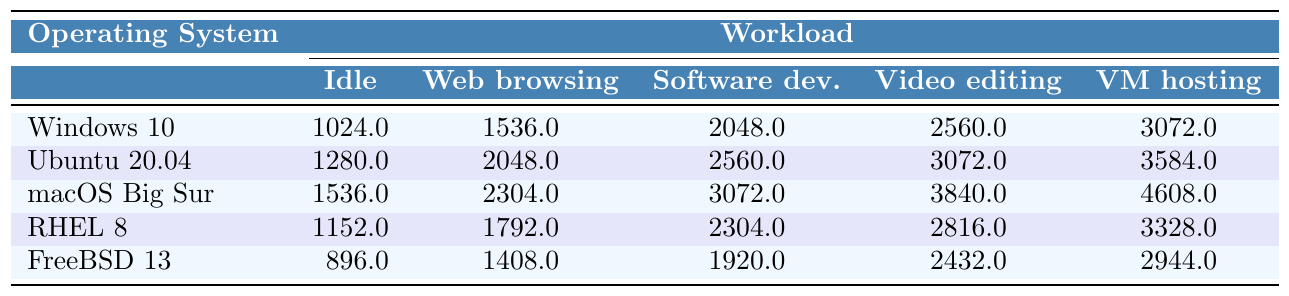What is the memory usage for Ubuntu 20.04 during video editing? From the table, look under Ubuntu 20.04 and the Video editing column. The value is 3072 MB.
Answer: 3072 MB Which operating system has the highest memory usage during software development? Check the Software development column for each operating system. The highest value is 3072 MB, which corresponds to macOS Big Sur.
Answer: macOS Big Sur What is the CPU utilization for FreeBSD 13 when idle? Refer to the Idle column for FreeBSD 13. The value is 1%.
Answer: 1% Which operating system shows the lowest disk I/O when hosting virtual machines? Look at the disk I/O under the VM hosting column. FreeBSD 13 has the lowest value at 90 MBps.
Answer: FreeBSD 13 What is the difference in memory usage between Windows 10 and RHEL 8 during web browsing? The memory usage for Windows 10 during web browsing is 1536 MB, while RHEL 8 is 1792 MB. The difference is 1792 - 1536 = 256 MB.
Answer: 256 MB What is the average memory usage across all operating systems during the idle workload? Sum the memory usage for the Idle column: 1024 + 1280 + 1536 + 1152 + 896 = 4888 MB. There are 5 operating systems, so the average is 4888 / 5 = 977.6 MB.
Answer: 977.6 MB Is Ubuntu 20.04's network usage during software development higher than macOS Big Sur's? For Ubuntu 20.04, the network usage during software development is 7 Mbps, and for macOS Big Sur, it is 8 Mbps. Therefore, 7 Mbps is not higher than 8 Mbps, the answer is no.
Answer: No Which operating system has the most processes running during video editing, and what is the count? Check the Video editing column for all operating systems. The highest count is 160 processes for macOS Big Sur.
Answer: macOS Big Sur with 160 processes If we consider the average memory usage during virtual machine hosting across all the operating systems, what is it? Summing the memory usage for VM hosting: 3072 + 3584 + 4608 + 3328 + 2944 = 17536 MB. Divide this by 5 (the number of operating systems): 17536 / 5 = 3507.2 MB.
Answer: 3507.2 MB What is the CPU utilization for macOS Big Sur during video editing compared to FreeBSD 13? For macOS Big Sur during video editing, the CPU utilization is 55%, while for FreeBSD 13 it is 42%. Therefore, macOS Big Sur has a higher utilization.
Answer: Yes, it is higher 